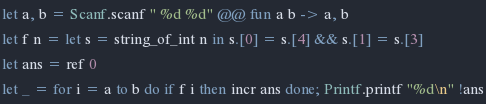<code> <loc_0><loc_0><loc_500><loc_500><_OCaml_>let a, b = Scanf.scanf " %d %d" @@ fun a b -> a, b
let f n = let s = string_of_int n in s.[0] = s.[4] && s.[1] = s.[3]
let ans = ref 0
let _ = for i = a to b do if f i then incr ans done; Printf.printf "%d\n" !ans</code> 